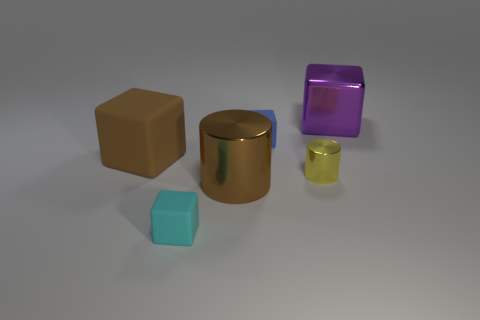Add 3 big objects. How many objects exist? 9 Subtract all large brown matte cubes. How many cubes are left? 3 Subtract all blue cubes. How many cubes are left? 3 Subtract 2 blocks. How many blocks are left? 2 Subtract all cubes. How many objects are left? 2 Add 6 tiny cyan cubes. How many tiny cyan cubes exist? 7 Subtract 1 brown cylinders. How many objects are left? 5 Subtract all blue cylinders. Subtract all yellow blocks. How many cylinders are left? 2 Subtract all big cyan cubes. Subtract all big brown matte objects. How many objects are left? 5 Add 2 big brown metallic cylinders. How many big brown metallic cylinders are left? 3 